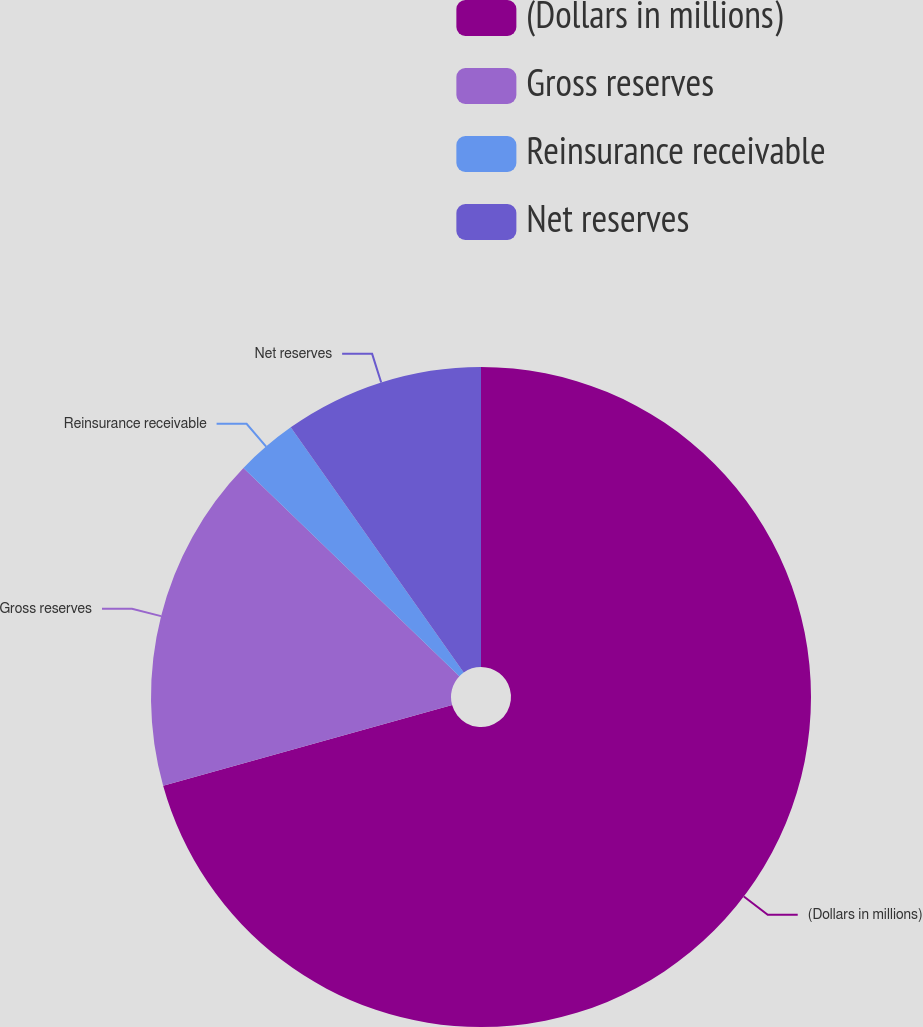Convert chart. <chart><loc_0><loc_0><loc_500><loc_500><pie_chart><fcel>(Dollars in millions)<fcel>Gross reserves<fcel>Reinsurance receivable<fcel>Net reserves<nl><fcel>70.67%<fcel>16.54%<fcel>3.01%<fcel>9.78%<nl></chart> 